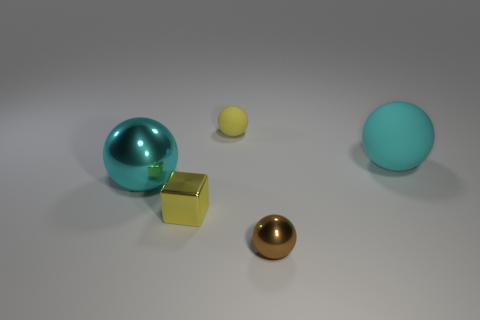Add 1 small cyan shiny spheres. How many objects exist? 6 Subtract all green spheres. Subtract all brown cubes. How many spheres are left? 4 Subtract all cubes. How many objects are left? 4 Subtract all brown spheres. Subtract all large green blocks. How many objects are left? 4 Add 5 big cyan matte balls. How many big cyan matte balls are left? 6 Add 5 cyan balls. How many cyan balls exist? 7 Subtract 1 yellow spheres. How many objects are left? 4 